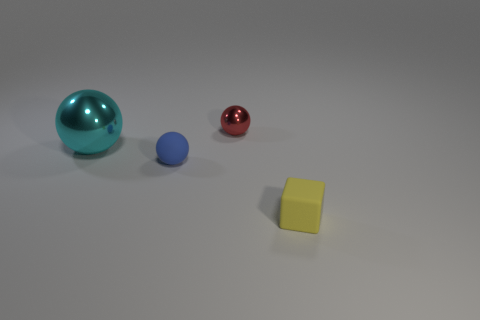How many tiny objects are in front of the small red metal ball and left of the rubber block?
Your answer should be very brief. 1. Are there any metallic things of the same color as the tiny matte ball?
Offer a terse response. No. What shape is the metal thing that is the same size as the blue matte object?
Make the answer very short. Sphere. Are there any tiny red things to the left of the red metal object?
Give a very brief answer. No. Do the tiny thing behind the blue thing and the ball that is in front of the cyan thing have the same material?
Provide a succinct answer. No. How many rubber objects are the same size as the matte ball?
Offer a terse response. 1. What is the material of the object to the left of the small blue rubber object?
Provide a short and direct response. Metal. How many other blue metallic things are the same shape as the blue thing?
Offer a very short reply. 0. There is a red thing that is the same material as the cyan object; what is its shape?
Keep it short and to the point. Sphere. What is the shape of the matte thing that is behind the small matte block in front of the tiny ball that is in front of the large cyan object?
Provide a succinct answer. Sphere. 